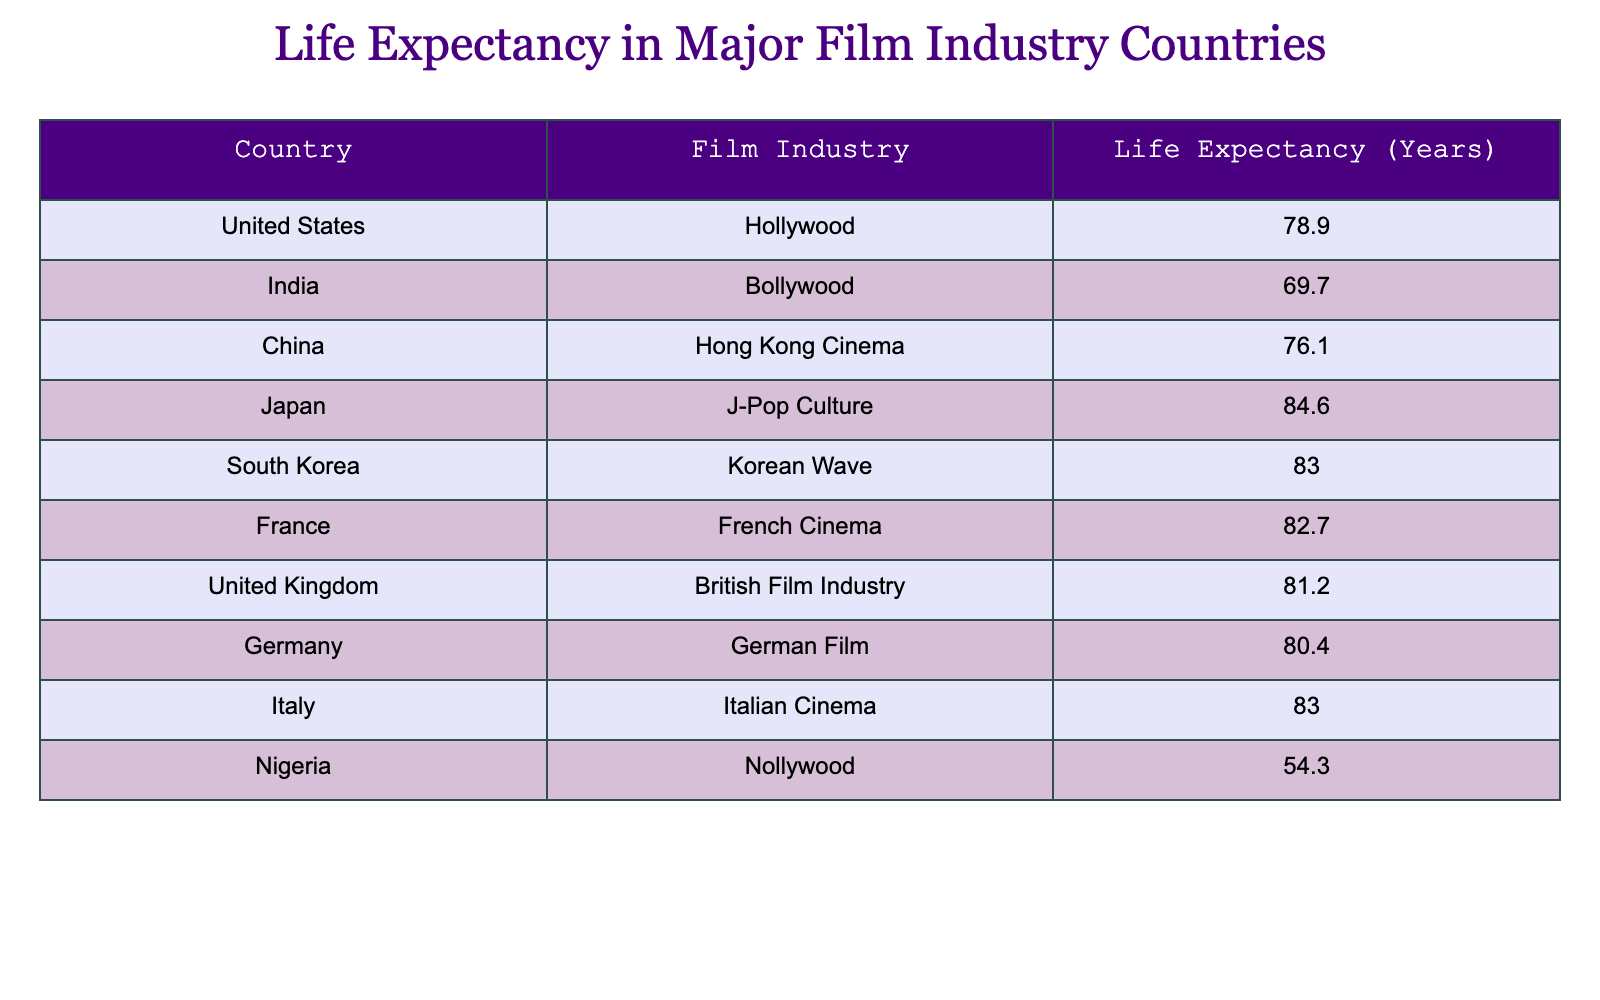What is the life expectancy in Japan? According to the table, the life expectancy for Japan is clearly listed under the "Life Expectancy (Years)" column, which shows 84.6 years.
Answer: 84.6 Which film industry country has the lowest life expectancy? By analyzing the "Life Expectancy (Years)" column, we can identify the lowest figure. The only country listed with a life expectancy of 54.3 years is Nigeria, indicating it has the lowest value in the table.
Answer: Nigeria What is the average life expectancy of the countries listed? To find the average, we first sum the life expectancies: 78.9 + 69.7 + 76.1 + 84.6 + 83.0 + 82.7 + 81.2 + 80.4 + 83.0 + 54.3 = 798.9. Then, we divide by the number of countries, which is 10. This results in an average life expectancy of 798.9/10 = 79.89 years.
Answer: 79.89 Is the life expectancy in India higher than that in Germany? Looking at the life expectancy figure for India, which is 69.7 years, and Germany, which is 80.4 years, we find that 69.7 is indeed less than 80.4. Therefore, it is false that India has a higher life expectancy than Germany.
Answer: No How many countries in the table have a life expectancy greater than 80 years? By counting the countries with a life expectancy exceeding 80 years, we find Japan (84.6), South Korea (83.0), Italy (83.0), France (82.7), and the United Kingdom (81.2). This gives us a total of 5 countries that meet the criterion.
Answer: 5 Which country has a life expectancy that is closest to the average of all listed countries? We previously calculated the average life expectancy to be 79.89 years. Comparing this figure to all the countries, we see that Germany has a life expectancy of 80.4, which is just 0.51 above the average, while the U.S. is at 78.9, which is 0.99 below the average. Germany is therefore closest to the average.
Answer: Germany Is the life expectancy for Bollywood films higher than for Nollywood films? Checking the values, Bollywood, representing India, has a life expectancy of 69.7, while Nollywood, representing Nigeria, has an even lower life expectancy of 54.3. Thus, it is true that Bollywood films have a higher life expectancy compared to Nollywood.
Answer: Yes What is the difference in life expectancy between the US and China? The life expectancy for the United States is 78.9 years, and for China, it is 76.1 years. To find the difference, we subtract the two values: 78.9 - 76.1 = 2.8 years. Therefore, there is a difference of 2.8 years between the two countries.
Answer: 2.8 